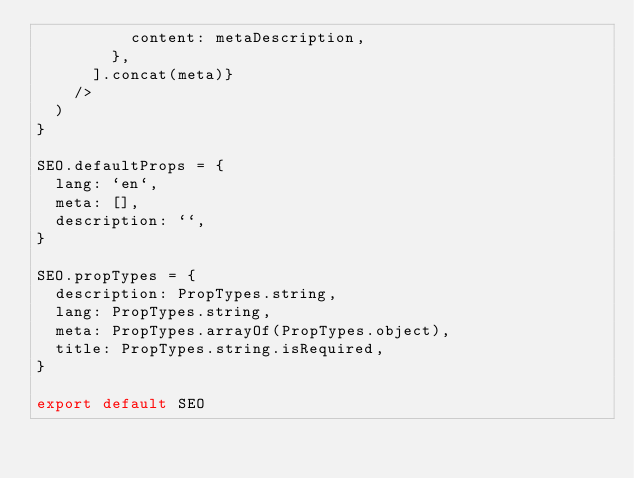<code> <loc_0><loc_0><loc_500><loc_500><_JavaScript_>          content: metaDescription,
        },
      ].concat(meta)}
    />
  )
}

SEO.defaultProps = {
  lang: `en`,
  meta: [],
  description: ``,
}

SEO.propTypes = {
  description: PropTypes.string,
  lang: PropTypes.string,
  meta: PropTypes.arrayOf(PropTypes.object),
  title: PropTypes.string.isRequired,
}

export default SEO
</code> 